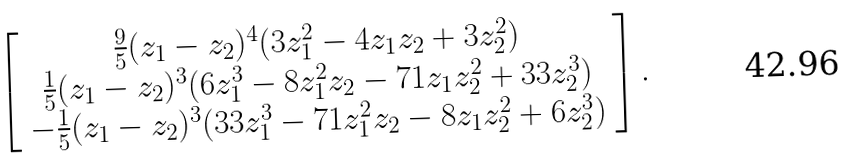Convert formula to latex. <formula><loc_0><loc_0><loc_500><loc_500>\left [ \begin{array} { c } \frac { 9 } { 5 } ( z _ { 1 } - z _ { 2 } ) ^ { 4 } ( 3 z _ { 1 } ^ { 2 } - 4 z _ { 1 } z _ { 2 } + 3 z _ { 2 } ^ { 2 } ) \\ \frac { 1 } { 5 } ( z _ { 1 } - z _ { 2 } ) ^ { 3 } ( 6 z _ { 1 } ^ { 3 } - 8 z _ { 1 } ^ { 2 } z _ { 2 } - 7 1 z _ { 1 } z _ { 2 } ^ { 2 } + 3 3 z _ { 2 } ^ { 3 } ) \\ - \frac { 1 } { 5 } ( z _ { 1 } - z _ { 2 } ) ^ { 3 } ( 3 3 z _ { 1 } ^ { 3 } - 7 1 z _ { 1 } ^ { 2 } z _ { 2 } - 8 z _ { 1 } z _ { 2 } ^ { 2 } + 6 z _ { 2 } ^ { 3 } ) \\ \end{array} \right ] .</formula> 